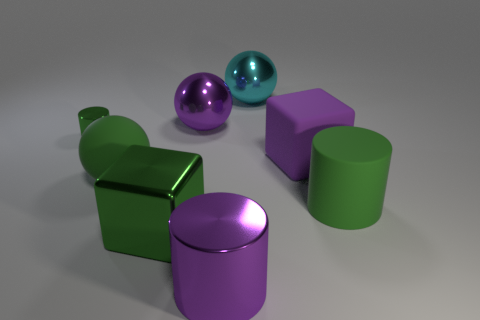The big object that is to the right of the large cyan shiny ball and in front of the green ball has what shape?
Give a very brief answer. Cylinder. Are there an equal number of shiny things in front of the purple matte object and big purple shiny objects that are on the right side of the big cyan thing?
Provide a succinct answer. No. What is the shape of the large metal object that is the same color as the small thing?
Provide a succinct answer. Cube. There is a large green thing behind the green matte cylinder; what is it made of?
Offer a very short reply. Rubber. Is the purple shiny cylinder the same size as the green shiny cube?
Make the answer very short. Yes. Are there more purple rubber things behind the large cyan thing than big purple metallic cylinders?
Make the answer very short. No. The purple cylinder that is made of the same material as the small thing is what size?
Provide a succinct answer. Large. There is a purple block; are there any large shiny objects on the right side of it?
Keep it short and to the point. No. Does the tiny green metallic thing have the same shape as the big green metallic object?
Provide a short and direct response. No. How big is the cylinder that is on the left side of the purple shiny object right of the large metal sphere to the left of the big cyan ball?
Your answer should be compact. Small. 